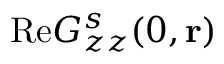<formula> <loc_0><loc_0><loc_500><loc_500>R e G _ { z z } ^ { s } ( 0 , { r } )</formula> 